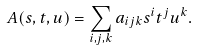<formula> <loc_0><loc_0><loc_500><loc_500>A ( s , t , u ) = \sum _ { i , j , k } a _ { i j k } s ^ { i } t ^ { j } u ^ { k } .</formula> 